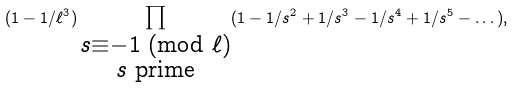<formula> <loc_0><loc_0><loc_500><loc_500>( 1 - 1 / \ell ^ { 3 } ) \prod _ { \substack { s \equiv - 1 \text { (mod $\ell$)} \\ s \text { prime} } } ( 1 - 1 / s ^ { 2 } + 1 / s ^ { 3 } - 1 / s ^ { 4 } + 1 / s ^ { 5 } - \dots ) ,</formula> 